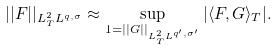<formula> <loc_0><loc_0><loc_500><loc_500>| | F | | _ { L ^ { 2 } _ { T } L ^ { q , \sigma } } \approx \sup _ { 1 = | | G | | _ { L ^ { 2 } _ { T } L ^ { q ^ { \prime } , \sigma ^ { \prime } } } } | \langle F , G \rangle _ { T } | .</formula> 